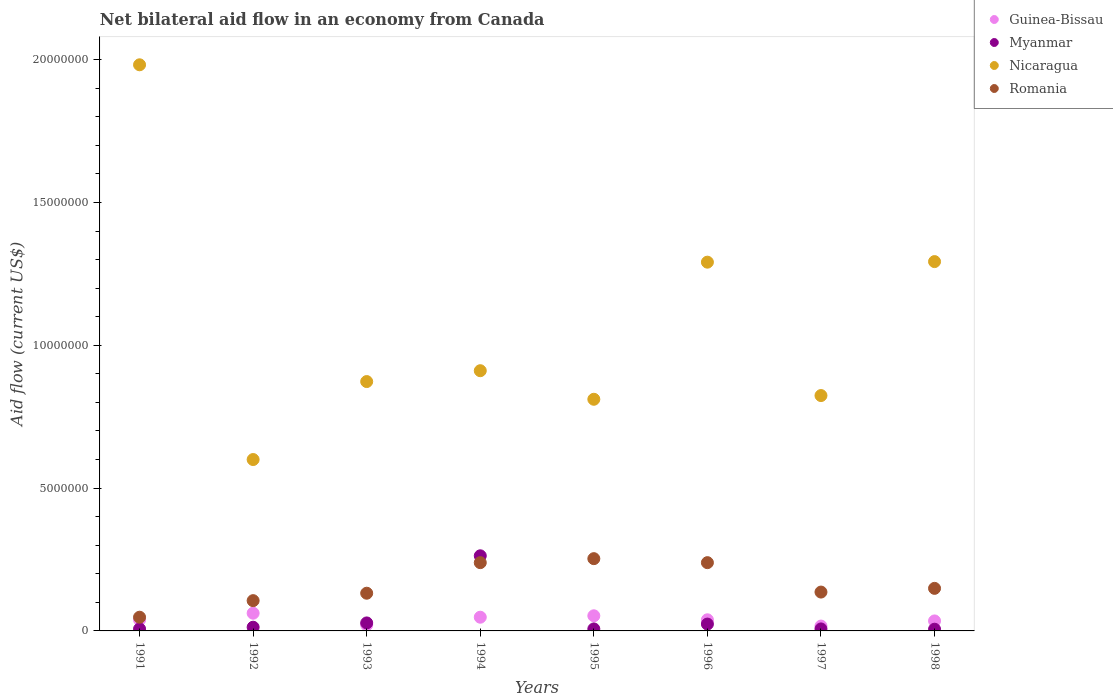Is the number of dotlines equal to the number of legend labels?
Offer a terse response. Yes. What is the net bilateral aid flow in Guinea-Bissau in 1998?
Your answer should be very brief. 3.50e+05. Across all years, what is the maximum net bilateral aid flow in Romania?
Your answer should be very brief. 2.53e+06. What is the total net bilateral aid flow in Myanmar in the graph?
Your answer should be very brief. 3.55e+06. What is the difference between the net bilateral aid flow in Romania in 1992 and that in 1995?
Give a very brief answer. -1.47e+06. What is the difference between the net bilateral aid flow in Romania in 1998 and the net bilateral aid flow in Guinea-Bissau in 1995?
Provide a succinct answer. 9.60e+05. What is the average net bilateral aid flow in Nicaragua per year?
Keep it short and to the point. 1.07e+07. In the year 1998, what is the difference between the net bilateral aid flow in Romania and net bilateral aid flow in Guinea-Bissau?
Give a very brief answer. 1.14e+06. What is the ratio of the net bilateral aid flow in Nicaragua in 1993 to that in 1997?
Your answer should be very brief. 1.06. What is the difference between the highest and the lowest net bilateral aid flow in Nicaragua?
Keep it short and to the point. 1.38e+07. In how many years, is the net bilateral aid flow in Myanmar greater than the average net bilateral aid flow in Myanmar taken over all years?
Ensure brevity in your answer.  1. Does the net bilateral aid flow in Romania monotonically increase over the years?
Offer a very short reply. No. Is the net bilateral aid flow in Guinea-Bissau strictly greater than the net bilateral aid flow in Myanmar over the years?
Your answer should be compact. No. Is the net bilateral aid flow in Romania strictly less than the net bilateral aid flow in Myanmar over the years?
Ensure brevity in your answer.  No. What is the difference between two consecutive major ticks on the Y-axis?
Make the answer very short. 5.00e+06. Are the values on the major ticks of Y-axis written in scientific E-notation?
Your response must be concise. No. Does the graph contain grids?
Make the answer very short. No. Where does the legend appear in the graph?
Offer a very short reply. Top right. How are the legend labels stacked?
Ensure brevity in your answer.  Vertical. What is the title of the graph?
Make the answer very short. Net bilateral aid flow in an economy from Canada. Does "Saudi Arabia" appear as one of the legend labels in the graph?
Provide a succinct answer. No. What is the label or title of the Y-axis?
Provide a short and direct response. Aid flow (current US$). What is the Aid flow (current US$) in Myanmar in 1991?
Give a very brief answer. 7.00e+04. What is the Aid flow (current US$) of Nicaragua in 1991?
Provide a succinct answer. 1.98e+07. What is the Aid flow (current US$) of Romania in 1991?
Your response must be concise. 4.80e+05. What is the Aid flow (current US$) in Guinea-Bissau in 1992?
Your answer should be very brief. 6.20e+05. What is the Aid flow (current US$) of Romania in 1992?
Your response must be concise. 1.06e+06. What is the Aid flow (current US$) in Nicaragua in 1993?
Give a very brief answer. 8.73e+06. What is the Aid flow (current US$) in Romania in 1993?
Offer a very short reply. 1.32e+06. What is the Aid flow (current US$) of Guinea-Bissau in 1994?
Ensure brevity in your answer.  4.80e+05. What is the Aid flow (current US$) in Myanmar in 1994?
Ensure brevity in your answer.  2.63e+06. What is the Aid flow (current US$) of Nicaragua in 1994?
Ensure brevity in your answer.  9.11e+06. What is the Aid flow (current US$) of Romania in 1994?
Give a very brief answer. 2.39e+06. What is the Aid flow (current US$) in Guinea-Bissau in 1995?
Keep it short and to the point. 5.30e+05. What is the Aid flow (current US$) in Nicaragua in 1995?
Your response must be concise. 8.11e+06. What is the Aid flow (current US$) in Romania in 1995?
Keep it short and to the point. 2.53e+06. What is the Aid flow (current US$) of Guinea-Bissau in 1996?
Provide a succinct answer. 3.90e+05. What is the Aid flow (current US$) of Nicaragua in 1996?
Provide a short and direct response. 1.29e+07. What is the Aid flow (current US$) of Romania in 1996?
Keep it short and to the point. 2.39e+06. What is the Aid flow (current US$) of Nicaragua in 1997?
Your answer should be compact. 8.24e+06. What is the Aid flow (current US$) of Romania in 1997?
Your answer should be very brief. 1.36e+06. What is the Aid flow (current US$) in Myanmar in 1998?
Offer a terse response. 6.00e+04. What is the Aid flow (current US$) of Nicaragua in 1998?
Keep it short and to the point. 1.29e+07. What is the Aid flow (current US$) of Romania in 1998?
Provide a short and direct response. 1.49e+06. Across all years, what is the maximum Aid flow (current US$) in Guinea-Bissau?
Make the answer very short. 6.20e+05. Across all years, what is the maximum Aid flow (current US$) in Myanmar?
Your response must be concise. 2.63e+06. Across all years, what is the maximum Aid flow (current US$) in Nicaragua?
Your response must be concise. 1.98e+07. Across all years, what is the maximum Aid flow (current US$) of Romania?
Your answer should be compact. 2.53e+06. Across all years, what is the minimum Aid flow (current US$) of Guinea-Bissau?
Offer a very short reply. 1.70e+05. Across all years, what is the minimum Aid flow (current US$) in Myanmar?
Make the answer very short. 6.00e+04. Across all years, what is the minimum Aid flow (current US$) in Nicaragua?
Ensure brevity in your answer.  6.00e+06. Across all years, what is the minimum Aid flow (current US$) in Romania?
Offer a terse response. 4.80e+05. What is the total Aid flow (current US$) of Guinea-Bissau in the graph?
Provide a short and direct response. 3.14e+06. What is the total Aid flow (current US$) of Myanmar in the graph?
Give a very brief answer. 3.55e+06. What is the total Aid flow (current US$) in Nicaragua in the graph?
Offer a terse response. 8.58e+07. What is the total Aid flow (current US$) in Romania in the graph?
Your response must be concise. 1.30e+07. What is the difference between the Aid flow (current US$) of Myanmar in 1991 and that in 1992?
Your answer should be compact. -6.00e+04. What is the difference between the Aid flow (current US$) in Nicaragua in 1991 and that in 1992?
Make the answer very short. 1.38e+07. What is the difference between the Aid flow (current US$) in Romania in 1991 and that in 1992?
Ensure brevity in your answer.  -5.80e+05. What is the difference between the Aid flow (current US$) in Guinea-Bissau in 1991 and that in 1993?
Make the answer very short. 1.80e+05. What is the difference between the Aid flow (current US$) of Myanmar in 1991 and that in 1993?
Provide a succinct answer. -2.10e+05. What is the difference between the Aid flow (current US$) in Nicaragua in 1991 and that in 1993?
Keep it short and to the point. 1.11e+07. What is the difference between the Aid flow (current US$) in Romania in 1991 and that in 1993?
Provide a short and direct response. -8.40e+05. What is the difference between the Aid flow (current US$) in Myanmar in 1991 and that in 1994?
Your response must be concise. -2.56e+06. What is the difference between the Aid flow (current US$) in Nicaragua in 1991 and that in 1994?
Your answer should be compact. 1.07e+07. What is the difference between the Aid flow (current US$) of Romania in 1991 and that in 1994?
Your response must be concise. -1.91e+06. What is the difference between the Aid flow (current US$) of Guinea-Bissau in 1991 and that in 1995?
Ensure brevity in your answer.  -1.40e+05. What is the difference between the Aid flow (current US$) in Nicaragua in 1991 and that in 1995?
Give a very brief answer. 1.17e+07. What is the difference between the Aid flow (current US$) of Romania in 1991 and that in 1995?
Make the answer very short. -2.05e+06. What is the difference between the Aid flow (current US$) of Guinea-Bissau in 1991 and that in 1996?
Make the answer very short. 0. What is the difference between the Aid flow (current US$) in Myanmar in 1991 and that in 1996?
Offer a very short reply. -1.70e+05. What is the difference between the Aid flow (current US$) in Nicaragua in 1991 and that in 1996?
Offer a very short reply. 6.91e+06. What is the difference between the Aid flow (current US$) of Romania in 1991 and that in 1996?
Make the answer very short. -1.91e+06. What is the difference between the Aid flow (current US$) of Guinea-Bissau in 1991 and that in 1997?
Provide a succinct answer. 2.20e+05. What is the difference between the Aid flow (current US$) of Nicaragua in 1991 and that in 1997?
Ensure brevity in your answer.  1.16e+07. What is the difference between the Aid flow (current US$) in Romania in 1991 and that in 1997?
Give a very brief answer. -8.80e+05. What is the difference between the Aid flow (current US$) of Guinea-Bissau in 1991 and that in 1998?
Your response must be concise. 4.00e+04. What is the difference between the Aid flow (current US$) of Nicaragua in 1991 and that in 1998?
Ensure brevity in your answer.  6.89e+06. What is the difference between the Aid flow (current US$) of Romania in 1991 and that in 1998?
Your answer should be very brief. -1.01e+06. What is the difference between the Aid flow (current US$) in Nicaragua in 1992 and that in 1993?
Your response must be concise. -2.73e+06. What is the difference between the Aid flow (current US$) of Romania in 1992 and that in 1993?
Your answer should be very brief. -2.60e+05. What is the difference between the Aid flow (current US$) in Myanmar in 1992 and that in 1994?
Your response must be concise. -2.50e+06. What is the difference between the Aid flow (current US$) of Nicaragua in 1992 and that in 1994?
Keep it short and to the point. -3.11e+06. What is the difference between the Aid flow (current US$) of Romania in 1992 and that in 1994?
Keep it short and to the point. -1.33e+06. What is the difference between the Aid flow (current US$) of Myanmar in 1992 and that in 1995?
Ensure brevity in your answer.  6.00e+04. What is the difference between the Aid flow (current US$) of Nicaragua in 1992 and that in 1995?
Provide a succinct answer. -2.11e+06. What is the difference between the Aid flow (current US$) of Romania in 1992 and that in 1995?
Ensure brevity in your answer.  -1.47e+06. What is the difference between the Aid flow (current US$) of Guinea-Bissau in 1992 and that in 1996?
Your answer should be very brief. 2.30e+05. What is the difference between the Aid flow (current US$) of Nicaragua in 1992 and that in 1996?
Your answer should be very brief. -6.91e+06. What is the difference between the Aid flow (current US$) of Romania in 1992 and that in 1996?
Provide a short and direct response. -1.33e+06. What is the difference between the Aid flow (current US$) in Nicaragua in 1992 and that in 1997?
Your answer should be compact. -2.24e+06. What is the difference between the Aid flow (current US$) of Romania in 1992 and that in 1997?
Your answer should be compact. -3.00e+05. What is the difference between the Aid flow (current US$) in Nicaragua in 1992 and that in 1998?
Give a very brief answer. -6.93e+06. What is the difference between the Aid flow (current US$) of Romania in 1992 and that in 1998?
Give a very brief answer. -4.30e+05. What is the difference between the Aid flow (current US$) in Myanmar in 1993 and that in 1994?
Offer a very short reply. -2.35e+06. What is the difference between the Aid flow (current US$) of Nicaragua in 1993 and that in 1994?
Offer a terse response. -3.80e+05. What is the difference between the Aid flow (current US$) in Romania in 1993 and that in 1994?
Your answer should be compact. -1.07e+06. What is the difference between the Aid flow (current US$) of Guinea-Bissau in 1993 and that in 1995?
Keep it short and to the point. -3.20e+05. What is the difference between the Aid flow (current US$) of Myanmar in 1993 and that in 1995?
Give a very brief answer. 2.10e+05. What is the difference between the Aid flow (current US$) in Nicaragua in 1993 and that in 1995?
Provide a succinct answer. 6.20e+05. What is the difference between the Aid flow (current US$) in Romania in 1993 and that in 1995?
Offer a terse response. -1.21e+06. What is the difference between the Aid flow (current US$) in Guinea-Bissau in 1993 and that in 1996?
Make the answer very short. -1.80e+05. What is the difference between the Aid flow (current US$) in Myanmar in 1993 and that in 1996?
Give a very brief answer. 4.00e+04. What is the difference between the Aid flow (current US$) of Nicaragua in 1993 and that in 1996?
Your answer should be compact. -4.18e+06. What is the difference between the Aid flow (current US$) of Romania in 1993 and that in 1996?
Your answer should be compact. -1.07e+06. What is the difference between the Aid flow (current US$) of Myanmar in 1993 and that in 1997?
Your answer should be very brief. 2.10e+05. What is the difference between the Aid flow (current US$) of Nicaragua in 1993 and that in 1997?
Ensure brevity in your answer.  4.90e+05. What is the difference between the Aid flow (current US$) in Guinea-Bissau in 1993 and that in 1998?
Your answer should be very brief. -1.40e+05. What is the difference between the Aid flow (current US$) of Myanmar in 1993 and that in 1998?
Ensure brevity in your answer.  2.20e+05. What is the difference between the Aid flow (current US$) in Nicaragua in 1993 and that in 1998?
Offer a terse response. -4.20e+06. What is the difference between the Aid flow (current US$) of Romania in 1993 and that in 1998?
Offer a terse response. -1.70e+05. What is the difference between the Aid flow (current US$) in Guinea-Bissau in 1994 and that in 1995?
Ensure brevity in your answer.  -5.00e+04. What is the difference between the Aid flow (current US$) in Myanmar in 1994 and that in 1995?
Give a very brief answer. 2.56e+06. What is the difference between the Aid flow (current US$) in Romania in 1994 and that in 1995?
Provide a short and direct response. -1.40e+05. What is the difference between the Aid flow (current US$) of Guinea-Bissau in 1994 and that in 1996?
Your answer should be compact. 9.00e+04. What is the difference between the Aid flow (current US$) in Myanmar in 1994 and that in 1996?
Your response must be concise. 2.39e+06. What is the difference between the Aid flow (current US$) of Nicaragua in 1994 and that in 1996?
Keep it short and to the point. -3.80e+06. What is the difference between the Aid flow (current US$) in Guinea-Bissau in 1994 and that in 1997?
Keep it short and to the point. 3.10e+05. What is the difference between the Aid flow (current US$) of Myanmar in 1994 and that in 1997?
Offer a very short reply. 2.56e+06. What is the difference between the Aid flow (current US$) in Nicaragua in 1994 and that in 1997?
Give a very brief answer. 8.70e+05. What is the difference between the Aid flow (current US$) of Romania in 1994 and that in 1997?
Provide a succinct answer. 1.03e+06. What is the difference between the Aid flow (current US$) of Guinea-Bissau in 1994 and that in 1998?
Your response must be concise. 1.30e+05. What is the difference between the Aid flow (current US$) in Myanmar in 1994 and that in 1998?
Provide a short and direct response. 2.57e+06. What is the difference between the Aid flow (current US$) of Nicaragua in 1994 and that in 1998?
Make the answer very short. -3.82e+06. What is the difference between the Aid flow (current US$) in Guinea-Bissau in 1995 and that in 1996?
Ensure brevity in your answer.  1.40e+05. What is the difference between the Aid flow (current US$) of Myanmar in 1995 and that in 1996?
Your answer should be very brief. -1.70e+05. What is the difference between the Aid flow (current US$) of Nicaragua in 1995 and that in 1996?
Your answer should be compact. -4.80e+06. What is the difference between the Aid flow (current US$) in Guinea-Bissau in 1995 and that in 1997?
Your answer should be compact. 3.60e+05. What is the difference between the Aid flow (current US$) of Nicaragua in 1995 and that in 1997?
Offer a very short reply. -1.30e+05. What is the difference between the Aid flow (current US$) in Romania in 1995 and that in 1997?
Keep it short and to the point. 1.17e+06. What is the difference between the Aid flow (current US$) in Myanmar in 1995 and that in 1998?
Ensure brevity in your answer.  10000. What is the difference between the Aid flow (current US$) in Nicaragua in 1995 and that in 1998?
Make the answer very short. -4.82e+06. What is the difference between the Aid flow (current US$) of Romania in 1995 and that in 1998?
Your answer should be compact. 1.04e+06. What is the difference between the Aid flow (current US$) in Myanmar in 1996 and that in 1997?
Offer a terse response. 1.70e+05. What is the difference between the Aid flow (current US$) of Nicaragua in 1996 and that in 1997?
Provide a short and direct response. 4.67e+06. What is the difference between the Aid flow (current US$) in Romania in 1996 and that in 1997?
Your answer should be compact. 1.03e+06. What is the difference between the Aid flow (current US$) of Guinea-Bissau in 1996 and that in 1998?
Provide a succinct answer. 4.00e+04. What is the difference between the Aid flow (current US$) of Nicaragua in 1996 and that in 1998?
Give a very brief answer. -2.00e+04. What is the difference between the Aid flow (current US$) of Romania in 1996 and that in 1998?
Your answer should be compact. 9.00e+05. What is the difference between the Aid flow (current US$) of Myanmar in 1997 and that in 1998?
Give a very brief answer. 10000. What is the difference between the Aid flow (current US$) in Nicaragua in 1997 and that in 1998?
Your answer should be compact. -4.69e+06. What is the difference between the Aid flow (current US$) of Romania in 1997 and that in 1998?
Offer a very short reply. -1.30e+05. What is the difference between the Aid flow (current US$) in Guinea-Bissau in 1991 and the Aid flow (current US$) in Myanmar in 1992?
Ensure brevity in your answer.  2.60e+05. What is the difference between the Aid flow (current US$) in Guinea-Bissau in 1991 and the Aid flow (current US$) in Nicaragua in 1992?
Provide a succinct answer. -5.61e+06. What is the difference between the Aid flow (current US$) of Guinea-Bissau in 1991 and the Aid flow (current US$) of Romania in 1992?
Make the answer very short. -6.70e+05. What is the difference between the Aid flow (current US$) of Myanmar in 1991 and the Aid flow (current US$) of Nicaragua in 1992?
Provide a succinct answer. -5.93e+06. What is the difference between the Aid flow (current US$) in Myanmar in 1991 and the Aid flow (current US$) in Romania in 1992?
Offer a very short reply. -9.90e+05. What is the difference between the Aid flow (current US$) in Nicaragua in 1991 and the Aid flow (current US$) in Romania in 1992?
Make the answer very short. 1.88e+07. What is the difference between the Aid flow (current US$) in Guinea-Bissau in 1991 and the Aid flow (current US$) in Nicaragua in 1993?
Offer a terse response. -8.34e+06. What is the difference between the Aid flow (current US$) in Guinea-Bissau in 1991 and the Aid flow (current US$) in Romania in 1993?
Ensure brevity in your answer.  -9.30e+05. What is the difference between the Aid flow (current US$) of Myanmar in 1991 and the Aid flow (current US$) of Nicaragua in 1993?
Give a very brief answer. -8.66e+06. What is the difference between the Aid flow (current US$) in Myanmar in 1991 and the Aid flow (current US$) in Romania in 1993?
Give a very brief answer. -1.25e+06. What is the difference between the Aid flow (current US$) of Nicaragua in 1991 and the Aid flow (current US$) of Romania in 1993?
Offer a very short reply. 1.85e+07. What is the difference between the Aid flow (current US$) of Guinea-Bissau in 1991 and the Aid flow (current US$) of Myanmar in 1994?
Give a very brief answer. -2.24e+06. What is the difference between the Aid flow (current US$) of Guinea-Bissau in 1991 and the Aid flow (current US$) of Nicaragua in 1994?
Your answer should be compact. -8.72e+06. What is the difference between the Aid flow (current US$) in Myanmar in 1991 and the Aid flow (current US$) in Nicaragua in 1994?
Your answer should be compact. -9.04e+06. What is the difference between the Aid flow (current US$) of Myanmar in 1991 and the Aid flow (current US$) of Romania in 1994?
Provide a short and direct response. -2.32e+06. What is the difference between the Aid flow (current US$) of Nicaragua in 1991 and the Aid flow (current US$) of Romania in 1994?
Give a very brief answer. 1.74e+07. What is the difference between the Aid flow (current US$) of Guinea-Bissau in 1991 and the Aid flow (current US$) of Myanmar in 1995?
Keep it short and to the point. 3.20e+05. What is the difference between the Aid flow (current US$) in Guinea-Bissau in 1991 and the Aid flow (current US$) in Nicaragua in 1995?
Your answer should be very brief. -7.72e+06. What is the difference between the Aid flow (current US$) of Guinea-Bissau in 1991 and the Aid flow (current US$) of Romania in 1995?
Your answer should be very brief. -2.14e+06. What is the difference between the Aid flow (current US$) of Myanmar in 1991 and the Aid flow (current US$) of Nicaragua in 1995?
Provide a succinct answer. -8.04e+06. What is the difference between the Aid flow (current US$) of Myanmar in 1991 and the Aid flow (current US$) of Romania in 1995?
Ensure brevity in your answer.  -2.46e+06. What is the difference between the Aid flow (current US$) in Nicaragua in 1991 and the Aid flow (current US$) in Romania in 1995?
Provide a succinct answer. 1.73e+07. What is the difference between the Aid flow (current US$) of Guinea-Bissau in 1991 and the Aid flow (current US$) of Nicaragua in 1996?
Keep it short and to the point. -1.25e+07. What is the difference between the Aid flow (current US$) in Guinea-Bissau in 1991 and the Aid flow (current US$) in Romania in 1996?
Offer a very short reply. -2.00e+06. What is the difference between the Aid flow (current US$) of Myanmar in 1991 and the Aid flow (current US$) of Nicaragua in 1996?
Your response must be concise. -1.28e+07. What is the difference between the Aid flow (current US$) of Myanmar in 1991 and the Aid flow (current US$) of Romania in 1996?
Provide a short and direct response. -2.32e+06. What is the difference between the Aid flow (current US$) in Nicaragua in 1991 and the Aid flow (current US$) in Romania in 1996?
Make the answer very short. 1.74e+07. What is the difference between the Aid flow (current US$) in Guinea-Bissau in 1991 and the Aid flow (current US$) in Nicaragua in 1997?
Your response must be concise. -7.85e+06. What is the difference between the Aid flow (current US$) in Guinea-Bissau in 1991 and the Aid flow (current US$) in Romania in 1997?
Your answer should be compact. -9.70e+05. What is the difference between the Aid flow (current US$) of Myanmar in 1991 and the Aid flow (current US$) of Nicaragua in 1997?
Your response must be concise. -8.17e+06. What is the difference between the Aid flow (current US$) in Myanmar in 1991 and the Aid flow (current US$) in Romania in 1997?
Make the answer very short. -1.29e+06. What is the difference between the Aid flow (current US$) of Nicaragua in 1991 and the Aid flow (current US$) of Romania in 1997?
Provide a short and direct response. 1.85e+07. What is the difference between the Aid flow (current US$) in Guinea-Bissau in 1991 and the Aid flow (current US$) in Myanmar in 1998?
Keep it short and to the point. 3.30e+05. What is the difference between the Aid flow (current US$) of Guinea-Bissau in 1991 and the Aid flow (current US$) of Nicaragua in 1998?
Keep it short and to the point. -1.25e+07. What is the difference between the Aid flow (current US$) in Guinea-Bissau in 1991 and the Aid flow (current US$) in Romania in 1998?
Make the answer very short. -1.10e+06. What is the difference between the Aid flow (current US$) in Myanmar in 1991 and the Aid flow (current US$) in Nicaragua in 1998?
Offer a very short reply. -1.29e+07. What is the difference between the Aid flow (current US$) of Myanmar in 1991 and the Aid flow (current US$) of Romania in 1998?
Make the answer very short. -1.42e+06. What is the difference between the Aid flow (current US$) in Nicaragua in 1991 and the Aid flow (current US$) in Romania in 1998?
Offer a terse response. 1.83e+07. What is the difference between the Aid flow (current US$) in Guinea-Bissau in 1992 and the Aid flow (current US$) in Nicaragua in 1993?
Provide a succinct answer. -8.11e+06. What is the difference between the Aid flow (current US$) of Guinea-Bissau in 1992 and the Aid flow (current US$) of Romania in 1993?
Provide a succinct answer. -7.00e+05. What is the difference between the Aid flow (current US$) in Myanmar in 1992 and the Aid flow (current US$) in Nicaragua in 1993?
Provide a short and direct response. -8.60e+06. What is the difference between the Aid flow (current US$) of Myanmar in 1992 and the Aid flow (current US$) of Romania in 1993?
Your answer should be very brief. -1.19e+06. What is the difference between the Aid flow (current US$) in Nicaragua in 1992 and the Aid flow (current US$) in Romania in 1993?
Make the answer very short. 4.68e+06. What is the difference between the Aid flow (current US$) in Guinea-Bissau in 1992 and the Aid flow (current US$) in Myanmar in 1994?
Ensure brevity in your answer.  -2.01e+06. What is the difference between the Aid flow (current US$) of Guinea-Bissau in 1992 and the Aid flow (current US$) of Nicaragua in 1994?
Give a very brief answer. -8.49e+06. What is the difference between the Aid flow (current US$) of Guinea-Bissau in 1992 and the Aid flow (current US$) of Romania in 1994?
Ensure brevity in your answer.  -1.77e+06. What is the difference between the Aid flow (current US$) of Myanmar in 1992 and the Aid flow (current US$) of Nicaragua in 1994?
Provide a short and direct response. -8.98e+06. What is the difference between the Aid flow (current US$) in Myanmar in 1992 and the Aid flow (current US$) in Romania in 1994?
Offer a terse response. -2.26e+06. What is the difference between the Aid flow (current US$) in Nicaragua in 1992 and the Aid flow (current US$) in Romania in 1994?
Give a very brief answer. 3.61e+06. What is the difference between the Aid flow (current US$) of Guinea-Bissau in 1992 and the Aid flow (current US$) of Nicaragua in 1995?
Give a very brief answer. -7.49e+06. What is the difference between the Aid flow (current US$) in Guinea-Bissau in 1992 and the Aid flow (current US$) in Romania in 1995?
Your response must be concise. -1.91e+06. What is the difference between the Aid flow (current US$) of Myanmar in 1992 and the Aid flow (current US$) of Nicaragua in 1995?
Give a very brief answer. -7.98e+06. What is the difference between the Aid flow (current US$) of Myanmar in 1992 and the Aid flow (current US$) of Romania in 1995?
Your answer should be very brief. -2.40e+06. What is the difference between the Aid flow (current US$) in Nicaragua in 1992 and the Aid flow (current US$) in Romania in 1995?
Provide a short and direct response. 3.47e+06. What is the difference between the Aid flow (current US$) in Guinea-Bissau in 1992 and the Aid flow (current US$) in Nicaragua in 1996?
Ensure brevity in your answer.  -1.23e+07. What is the difference between the Aid flow (current US$) of Guinea-Bissau in 1992 and the Aid flow (current US$) of Romania in 1996?
Ensure brevity in your answer.  -1.77e+06. What is the difference between the Aid flow (current US$) of Myanmar in 1992 and the Aid flow (current US$) of Nicaragua in 1996?
Offer a very short reply. -1.28e+07. What is the difference between the Aid flow (current US$) of Myanmar in 1992 and the Aid flow (current US$) of Romania in 1996?
Provide a short and direct response. -2.26e+06. What is the difference between the Aid flow (current US$) in Nicaragua in 1992 and the Aid flow (current US$) in Romania in 1996?
Your answer should be very brief. 3.61e+06. What is the difference between the Aid flow (current US$) of Guinea-Bissau in 1992 and the Aid flow (current US$) of Myanmar in 1997?
Make the answer very short. 5.50e+05. What is the difference between the Aid flow (current US$) of Guinea-Bissau in 1992 and the Aid flow (current US$) of Nicaragua in 1997?
Your answer should be compact. -7.62e+06. What is the difference between the Aid flow (current US$) in Guinea-Bissau in 1992 and the Aid flow (current US$) in Romania in 1997?
Ensure brevity in your answer.  -7.40e+05. What is the difference between the Aid flow (current US$) of Myanmar in 1992 and the Aid flow (current US$) of Nicaragua in 1997?
Your answer should be very brief. -8.11e+06. What is the difference between the Aid flow (current US$) of Myanmar in 1992 and the Aid flow (current US$) of Romania in 1997?
Offer a terse response. -1.23e+06. What is the difference between the Aid flow (current US$) of Nicaragua in 1992 and the Aid flow (current US$) of Romania in 1997?
Your answer should be compact. 4.64e+06. What is the difference between the Aid flow (current US$) in Guinea-Bissau in 1992 and the Aid flow (current US$) in Myanmar in 1998?
Your answer should be very brief. 5.60e+05. What is the difference between the Aid flow (current US$) of Guinea-Bissau in 1992 and the Aid flow (current US$) of Nicaragua in 1998?
Your answer should be compact. -1.23e+07. What is the difference between the Aid flow (current US$) in Guinea-Bissau in 1992 and the Aid flow (current US$) in Romania in 1998?
Offer a very short reply. -8.70e+05. What is the difference between the Aid flow (current US$) of Myanmar in 1992 and the Aid flow (current US$) of Nicaragua in 1998?
Provide a succinct answer. -1.28e+07. What is the difference between the Aid flow (current US$) in Myanmar in 1992 and the Aid flow (current US$) in Romania in 1998?
Your answer should be very brief. -1.36e+06. What is the difference between the Aid flow (current US$) of Nicaragua in 1992 and the Aid flow (current US$) of Romania in 1998?
Offer a very short reply. 4.51e+06. What is the difference between the Aid flow (current US$) of Guinea-Bissau in 1993 and the Aid flow (current US$) of Myanmar in 1994?
Your answer should be compact. -2.42e+06. What is the difference between the Aid flow (current US$) in Guinea-Bissau in 1993 and the Aid flow (current US$) in Nicaragua in 1994?
Offer a terse response. -8.90e+06. What is the difference between the Aid flow (current US$) in Guinea-Bissau in 1993 and the Aid flow (current US$) in Romania in 1994?
Your answer should be very brief. -2.18e+06. What is the difference between the Aid flow (current US$) in Myanmar in 1993 and the Aid flow (current US$) in Nicaragua in 1994?
Offer a terse response. -8.83e+06. What is the difference between the Aid flow (current US$) in Myanmar in 1993 and the Aid flow (current US$) in Romania in 1994?
Make the answer very short. -2.11e+06. What is the difference between the Aid flow (current US$) of Nicaragua in 1993 and the Aid flow (current US$) of Romania in 1994?
Give a very brief answer. 6.34e+06. What is the difference between the Aid flow (current US$) in Guinea-Bissau in 1993 and the Aid flow (current US$) in Myanmar in 1995?
Make the answer very short. 1.40e+05. What is the difference between the Aid flow (current US$) in Guinea-Bissau in 1993 and the Aid flow (current US$) in Nicaragua in 1995?
Your response must be concise. -7.90e+06. What is the difference between the Aid flow (current US$) in Guinea-Bissau in 1993 and the Aid flow (current US$) in Romania in 1995?
Give a very brief answer. -2.32e+06. What is the difference between the Aid flow (current US$) of Myanmar in 1993 and the Aid flow (current US$) of Nicaragua in 1995?
Your answer should be very brief. -7.83e+06. What is the difference between the Aid flow (current US$) of Myanmar in 1993 and the Aid flow (current US$) of Romania in 1995?
Your answer should be compact. -2.25e+06. What is the difference between the Aid flow (current US$) in Nicaragua in 1993 and the Aid flow (current US$) in Romania in 1995?
Make the answer very short. 6.20e+06. What is the difference between the Aid flow (current US$) of Guinea-Bissau in 1993 and the Aid flow (current US$) of Nicaragua in 1996?
Provide a succinct answer. -1.27e+07. What is the difference between the Aid flow (current US$) in Guinea-Bissau in 1993 and the Aid flow (current US$) in Romania in 1996?
Your answer should be compact. -2.18e+06. What is the difference between the Aid flow (current US$) of Myanmar in 1993 and the Aid flow (current US$) of Nicaragua in 1996?
Ensure brevity in your answer.  -1.26e+07. What is the difference between the Aid flow (current US$) of Myanmar in 1993 and the Aid flow (current US$) of Romania in 1996?
Give a very brief answer. -2.11e+06. What is the difference between the Aid flow (current US$) of Nicaragua in 1993 and the Aid flow (current US$) of Romania in 1996?
Provide a short and direct response. 6.34e+06. What is the difference between the Aid flow (current US$) in Guinea-Bissau in 1993 and the Aid flow (current US$) in Myanmar in 1997?
Provide a short and direct response. 1.40e+05. What is the difference between the Aid flow (current US$) in Guinea-Bissau in 1993 and the Aid flow (current US$) in Nicaragua in 1997?
Ensure brevity in your answer.  -8.03e+06. What is the difference between the Aid flow (current US$) in Guinea-Bissau in 1993 and the Aid flow (current US$) in Romania in 1997?
Provide a short and direct response. -1.15e+06. What is the difference between the Aid flow (current US$) of Myanmar in 1993 and the Aid flow (current US$) of Nicaragua in 1997?
Give a very brief answer. -7.96e+06. What is the difference between the Aid flow (current US$) of Myanmar in 1993 and the Aid flow (current US$) of Romania in 1997?
Keep it short and to the point. -1.08e+06. What is the difference between the Aid flow (current US$) in Nicaragua in 1993 and the Aid flow (current US$) in Romania in 1997?
Provide a short and direct response. 7.37e+06. What is the difference between the Aid flow (current US$) in Guinea-Bissau in 1993 and the Aid flow (current US$) in Myanmar in 1998?
Your response must be concise. 1.50e+05. What is the difference between the Aid flow (current US$) in Guinea-Bissau in 1993 and the Aid flow (current US$) in Nicaragua in 1998?
Provide a succinct answer. -1.27e+07. What is the difference between the Aid flow (current US$) of Guinea-Bissau in 1993 and the Aid flow (current US$) of Romania in 1998?
Offer a terse response. -1.28e+06. What is the difference between the Aid flow (current US$) of Myanmar in 1993 and the Aid flow (current US$) of Nicaragua in 1998?
Ensure brevity in your answer.  -1.26e+07. What is the difference between the Aid flow (current US$) in Myanmar in 1993 and the Aid flow (current US$) in Romania in 1998?
Ensure brevity in your answer.  -1.21e+06. What is the difference between the Aid flow (current US$) of Nicaragua in 1993 and the Aid flow (current US$) of Romania in 1998?
Provide a succinct answer. 7.24e+06. What is the difference between the Aid flow (current US$) in Guinea-Bissau in 1994 and the Aid flow (current US$) in Nicaragua in 1995?
Your answer should be compact. -7.63e+06. What is the difference between the Aid flow (current US$) in Guinea-Bissau in 1994 and the Aid flow (current US$) in Romania in 1995?
Provide a short and direct response. -2.05e+06. What is the difference between the Aid flow (current US$) of Myanmar in 1994 and the Aid flow (current US$) of Nicaragua in 1995?
Offer a very short reply. -5.48e+06. What is the difference between the Aid flow (current US$) in Myanmar in 1994 and the Aid flow (current US$) in Romania in 1995?
Ensure brevity in your answer.  1.00e+05. What is the difference between the Aid flow (current US$) of Nicaragua in 1994 and the Aid flow (current US$) of Romania in 1995?
Offer a terse response. 6.58e+06. What is the difference between the Aid flow (current US$) in Guinea-Bissau in 1994 and the Aid flow (current US$) in Nicaragua in 1996?
Provide a succinct answer. -1.24e+07. What is the difference between the Aid flow (current US$) of Guinea-Bissau in 1994 and the Aid flow (current US$) of Romania in 1996?
Provide a succinct answer. -1.91e+06. What is the difference between the Aid flow (current US$) in Myanmar in 1994 and the Aid flow (current US$) in Nicaragua in 1996?
Provide a short and direct response. -1.03e+07. What is the difference between the Aid flow (current US$) of Nicaragua in 1994 and the Aid flow (current US$) of Romania in 1996?
Provide a short and direct response. 6.72e+06. What is the difference between the Aid flow (current US$) of Guinea-Bissau in 1994 and the Aid flow (current US$) of Myanmar in 1997?
Provide a succinct answer. 4.10e+05. What is the difference between the Aid flow (current US$) in Guinea-Bissau in 1994 and the Aid flow (current US$) in Nicaragua in 1997?
Provide a succinct answer. -7.76e+06. What is the difference between the Aid flow (current US$) of Guinea-Bissau in 1994 and the Aid flow (current US$) of Romania in 1997?
Provide a succinct answer. -8.80e+05. What is the difference between the Aid flow (current US$) in Myanmar in 1994 and the Aid flow (current US$) in Nicaragua in 1997?
Make the answer very short. -5.61e+06. What is the difference between the Aid flow (current US$) in Myanmar in 1994 and the Aid flow (current US$) in Romania in 1997?
Offer a very short reply. 1.27e+06. What is the difference between the Aid flow (current US$) of Nicaragua in 1994 and the Aid flow (current US$) of Romania in 1997?
Keep it short and to the point. 7.75e+06. What is the difference between the Aid flow (current US$) in Guinea-Bissau in 1994 and the Aid flow (current US$) in Myanmar in 1998?
Your answer should be compact. 4.20e+05. What is the difference between the Aid flow (current US$) of Guinea-Bissau in 1994 and the Aid flow (current US$) of Nicaragua in 1998?
Your answer should be very brief. -1.24e+07. What is the difference between the Aid flow (current US$) in Guinea-Bissau in 1994 and the Aid flow (current US$) in Romania in 1998?
Your answer should be compact. -1.01e+06. What is the difference between the Aid flow (current US$) in Myanmar in 1994 and the Aid flow (current US$) in Nicaragua in 1998?
Make the answer very short. -1.03e+07. What is the difference between the Aid flow (current US$) in Myanmar in 1994 and the Aid flow (current US$) in Romania in 1998?
Ensure brevity in your answer.  1.14e+06. What is the difference between the Aid flow (current US$) of Nicaragua in 1994 and the Aid flow (current US$) of Romania in 1998?
Your answer should be compact. 7.62e+06. What is the difference between the Aid flow (current US$) of Guinea-Bissau in 1995 and the Aid flow (current US$) of Myanmar in 1996?
Provide a short and direct response. 2.90e+05. What is the difference between the Aid flow (current US$) of Guinea-Bissau in 1995 and the Aid flow (current US$) of Nicaragua in 1996?
Ensure brevity in your answer.  -1.24e+07. What is the difference between the Aid flow (current US$) in Guinea-Bissau in 1995 and the Aid flow (current US$) in Romania in 1996?
Your answer should be compact. -1.86e+06. What is the difference between the Aid flow (current US$) in Myanmar in 1995 and the Aid flow (current US$) in Nicaragua in 1996?
Offer a terse response. -1.28e+07. What is the difference between the Aid flow (current US$) of Myanmar in 1995 and the Aid flow (current US$) of Romania in 1996?
Offer a very short reply. -2.32e+06. What is the difference between the Aid flow (current US$) of Nicaragua in 1995 and the Aid flow (current US$) of Romania in 1996?
Provide a succinct answer. 5.72e+06. What is the difference between the Aid flow (current US$) in Guinea-Bissau in 1995 and the Aid flow (current US$) in Myanmar in 1997?
Provide a short and direct response. 4.60e+05. What is the difference between the Aid flow (current US$) of Guinea-Bissau in 1995 and the Aid flow (current US$) of Nicaragua in 1997?
Your response must be concise. -7.71e+06. What is the difference between the Aid flow (current US$) in Guinea-Bissau in 1995 and the Aid flow (current US$) in Romania in 1997?
Make the answer very short. -8.30e+05. What is the difference between the Aid flow (current US$) in Myanmar in 1995 and the Aid flow (current US$) in Nicaragua in 1997?
Offer a very short reply. -8.17e+06. What is the difference between the Aid flow (current US$) of Myanmar in 1995 and the Aid flow (current US$) of Romania in 1997?
Make the answer very short. -1.29e+06. What is the difference between the Aid flow (current US$) of Nicaragua in 1995 and the Aid flow (current US$) of Romania in 1997?
Give a very brief answer. 6.75e+06. What is the difference between the Aid flow (current US$) of Guinea-Bissau in 1995 and the Aid flow (current US$) of Myanmar in 1998?
Your answer should be compact. 4.70e+05. What is the difference between the Aid flow (current US$) of Guinea-Bissau in 1995 and the Aid flow (current US$) of Nicaragua in 1998?
Offer a terse response. -1.24e+07. What is the difference between the Aid flow (current US$) of Guinea-Bissau in 1995 and the Aid flow (current US$) of Romania in 1998?
Offer a terse response. -9.60e+05. What is the difference between the Aid flow (current US$) in Myanmar in 1995 and the Aid flow (current US$) in Nicaragua in 1998?
Give a very brief answer. -1.29e+07. What is the difference between the Aid flow (current US$) of Myanmar in 1995 and the Aid flow (current US$) of Romania in 1998?
Your answer should be compact. -1.42e+06. What is the difference between the Aid flow (current US$) of Nicaragua in 1995 and the Aid flow (current US$) of Romania in 1998?
Your response must be concise. 6.62e+06. What is the difference between the Aid flow (current US$) of Guinea-Bissau in 1996 and the Aid flow (current US$) of Myanmar in 1997?
Ensure brevity in your answer.  3.20e+05. What is the difference between the Aid flow (current US$) of Guinea-Bissau in 1996 and the Aid flow (current US$) of Nicaragua in 1997?
Ensure brevity in your answer.  -7.85e+06. What is the difference between the Aid flow (current US$) of Guinea-Bissau in 1996 and the Aid flow (current US$) of Romania in 1997?
Your answer should be compact. -9.70e+05. What is the difference between the Aid flow (current US$) in Myanmar in 1996 and the Aid flow (current US$) in Nicaragua in 1997?
Give a very brief answer. -8.00e+06. What is the difference between the Aid flow (current US$) of Myanmar in 1996 and the Aid flow (current US$) of Romania in 1997?
Keep it short and to the point. -1.12e+06. What is the difference between the Aid flow (current US$) of Nicaragua in 1996 and the Aid flow (current US$) of Romania in 1997?
Your response must be concise. 1.16e+07. What is the difference between the Aid flow (current US$) in Guinea-Bissau in 1996 and the Aid flow (current US$) in Myanmar in 1998?
Offer a very short reply. 3.30e+05. What is the difference between the Aid flow (current US$) of Guinea-Bissau in 1996 and the Aid flow (current US$) of Nicaragua in 1998?
Ensure brevity in your answer.  -1.25e+07. What is the difference between the Aid flow (current US$) in Guinea-Bissau in 1996 and the Aid flow (current US$) in Romania in 1998?
Keep it short and to the point. -1.10e+06. What is the difference between the Aid flow (current US$) of Myanmar in 1996 and the Aid flow (current US$) of Nicaragua in 1998?
Provide a short and direct response. -1.27e+07. What is the difference between the Aid flow (current US$) of Myanmar in 1996 and the Aid flow (current US$) of Romania in 1998?
Make the answer very short. -1.25e+06. What is the difference between the Aid flow (current US$) in Nicaragua in 1996 and the Aid flow (current US$) in Romania in 1998?
Ensure brevity in your answer.  1.14e+07. What is the difference between the Aid flow (current US$) in Guinea-Bissau in 1997 and the Aid flow (current US$) in Myanmar in 1998?
Offer a very short reply. 1.10e+05. What is the difference between the Aid flow (current US$) in Guinea-Bissau in 1997 and the Aid flow (current US$) in Nicaragua in 1998?
Provide a short and direct response. -1.28e+07. What is the difference between the Aid flow (current US$) of Guinea-Bissau in 1997 and the Aid flow (current US$) of Romania in 1998?
Offer a terse response. -1.32e+06. What is the difference between the Aid flow (current US$) in Myanmar in 1997 and the Aid flow (current US$) in Nicaragua in 1998?
Your answer should be very brief. -1.29e+07. What is the difference between the Aid flow (current US$) of Myanmar in 1997 and the Aid flow (current US$) of Romania in 1998?
Provide a short and direct response. -1.42e+06. What is the difference between the Aid flow (current US$) in Nicaragua in 1997 and the Aid flow (current US$) in Romania in 1998?
Your answer should be compact. 6.75e+06. What is the average Aid flow (current US$) in Guinea-Bissau per year?
Ensure brevity in your answer.  3.92e+05. What is the average Aid flow (current US$) of Myanmar per year?
Give a very brief answer. 4.44e+05. What is the average Aid flow (current US$) in Nicaragua per year?
Your answer should be compact. 1.07e+07. What is the average Aid flow (current US$) in Romania per year?
Give a very brief answer. 1.63e+06. In the year 1991, what is the difference between the Aid flow (current US$) of Guinea-Bissau and Aid flow (current US$) of Nicaragua?
Keep it short and to the point. -1.94e+07. In the year 1991, what is the difference between the Aid flow (current US$) of Myanmar and Aid flow (current US$) of Nicaragua?
Give a very brief answer. -1.98e+07. In the year 1991, what is the difference between the Aid flow (current US$) in Myanmar and Aid flow (current US$) in Romania?
Ensure brevity in your answer.  -4.10e+05. In the year 1991, what is the difference between the Aid flow (current US$) in Nicaragua and Aid flow (current US$) in Romania?
Provide a succinct answer. 1.93e+07. In the year 1992, what is the difference between the Aid flow (current US$) in Guinea-Bissau and Aid flow (current US$) in Myanmar?
Keep it short and to the point. 4.90e+05. In the year 1992, what is the difference between the Aid flow (current US$) of Guinea-Bissau and Aid flow (current US$) of Nicaragua?
Your response must be concise. -5.38e+06. In the year 1992, what is the difference between the Aid flow (current US$) of Guinea-Bissau and Aid flow (current US$) of Romania?
Your answer should be compact. -4.40e+05. In the year 1992, what is the difference between the Aid flow (current US$) of Myanmar and Aid flow (current US$) of Nicaragua?
Offer a very short reply. -5.87e+06. In the year 1992, what is the difference between the Aid flow (current US$) in Myanmar and Aid flow (current US$) in Romania?
Your answer should be very brief. -9.30e+05. In the year 1992, what is the difference between the Aid flow (current US$) of Nicaragua and Aid flow (current US$) of Romania?
Your answer should be compact. 4.94e+06. In the year 1993, what is the difference between the Aid flow (current US$) of Guinea-Bissau and Aid flow (current US$) of Nicaragua?
Your answer should be compact. -8.52e+06. In the year 1993, what is the difference between the Aid flow (current US$) of Guinea-Bissau and Aid flow (current US$) of Romania?
Offer a terse response. -1.11e+06. In the year 1993, what is the difference between the Aid flow (current US$) of Myanmar and Aid flow (current US$) of Nicaragua?
Offer a terse response. -8.45e+06. In the year 1993, what is the difference between the Aid flow (current US$) in Myanmar and Aid flow (current US$) in Romania?
Offer a terse response. -1.04e+06. In the year 1993, what is the difference between the Aid flow (current US$) in Nicaragua and Aid flow (current US$) in Romania?
Your answer should be very brief. 7.41e+06. In the year 1994, what is the difference between the Aid flow (current US$) of Guinea-Bissau and Aid flow (current US$) of Myanmar?
Provide a succinct answer. -2.15e+06. In the year 1994, what is the difference between the Aid flow (current US$) of Guinea-Bissau and Aid flow (current US$) of Nicaragua?
Keep it short and to the point. -8.63e+06. In the year 1994, what is the difference between the Aid flow (current US$) in Guinea-Bissau and Aid flow (current US$) in Romania?
Give a very brief answer. -1.91e+06. In the year 1994, what is the difference between the Aid flow (current US$) in Myanmar and Aid flow (current US$) in Nicaragua?
Offer a very short reply. -6.48e+06. In the year 1994, what is the difference between the Aid flow (current US$) in Myanmar and Aid flow (current US$) in Romania?
Ensure brevity in your answer.  2.40e+05. In the year 1994, what is the difference between the Aid flow (current US$) of Nicaragua and Aid flow (current US$) of Romania?
Give a very brief answer. 6.72e+06. In the year 1995, what is the difference between the Aid flow (current US$) of Guinea-Bissau and Aid flow (current US$) of Nicaragua?
Your answer should be compact. -7.58e+06. In the year 1995, what is the difference between the Aid flow (current US$) of Myanmar and Aid flow (current US$) of Nicaragua?
Your response must be concise. -8.04e+06. In the year 1995, what is the difference between the Aid flow (current US$) of Myanmar and Aid flow (current US$) of Romania?
Ensure brevity in your answer.  -2.46e+06. In the year 1995, what is the difference between the Aid flow (current US$) of Nicaragua and Aid flow (current US$) of Romania?
Your answer should be very brief. 5.58e+06. In the year 1996, what is the difference between the Aid flow (current US$) in Guinea-Bissau and Aid flow (current US$) in Myanmar?
Offer a very short reply. 1.50e+05. In the year 1996, what is the difference between the Aid flow (current US$) in Guinea-Bissau and Aid flow (current US$) in Nicaragua?
Your answer should be compact. -1.25e+07. In the year 1996, what is the difference between the Aid flow (current US$) in Guinea-Bissau and Aid flow (current US$) in Romania?
Ensure brevity in your answer.  -2.00e+06. In the year 1996, what is the difference between the Aid flow (current US$) in Myanmar and Aid flow (current US$) in Nicaragua?
Give a very brief answer. -1.27e+07. In the year 1996, what is the difference between the Aid flow (current US$) in Myanmar and Aid flow (current US$) in Romania?
Your answer should be compact. -2.15e+06. In the year 1996, what is the difference between the Aid flow (current US$) in Nicaragua and Aid flow (current US$) in Romania?
Your answer should be very brief. 1.05e+07. In the year 1997, what is the difference between the Aid flow (current US$) in Guinea-Bissau and Aid flow (current US$) in Myanmar?
Make the answer very short. 1.00e+05. In the year 1997, what is the difference between the Aid flow (current US$) of Guinea-Bissau and Aid flow (current US$) of Nicaragua?
Make the answer very short. -8.07e+06. In the year 1997, what is the difference between the Aid flow (current US$) of Guinea-Bissau and Aid flow (current US$) of Romania?
Your response must be concise. -1.19e+06. In the year 1997, what is the difference between the Aid flow (current US$) in Myanmar and Aid flow (current US$) in Nicaragua?
Give a very brief answer. -8.17e+06. In the year 1997, what is the difference between the Aid flow (current US$) of Myanmar and Aid flow (current US$) of Romania?
Keep it short and to the point. -1.29e+06. In the year 1997, what is the difference between the Aid flow (current US$) of Nicaragua and Aid flow (current US$) of Romania?
Ensure brevity in your answer.  6.88e+06. In the year 1998, what is the difference between the Aid flow (current US$) in Guinea-Bissau and Aid flow (current US$) in Nicaragua?
Give a very brief answer. -1.26e+07. In the year 1998, what is the difference between the Aid flow (current US$) of Guinea-Bissau and Aid flow (current US$) of Romania?
Provide a succinct answer. -1.14e+06. In the year 1998, what is the difference between the Aid flow (current US$) in Myanmar and Aid flow (current US$) in Nicaragua?
Make the answer very short. -1.29e+07. In the year 1998, what is the difference between the Aid flow (current US$) of Myanmar and Aid flow (current US$) of Romania?
Your response must be concise. -1.43e+06. In the year 1998, what is the difference between the Aid flow (current US$) of Nicaragua and Aid flow (current US$) of Romania?
Your answer should be very brief. 1.14e+07. What is the ratio of the Aid flow (current US$) in Guinea-Bissau in 1991 to that in 1992?
Offer a terse response. 0.63. What is the ratio of the Aid flow (current US$) of Myanmar in 1991 to that in 1992?
Offer a terse response. 0.54. What is the ratio of the Aid flow (current US$) of Nicaragua in 1991 to that in 1992?
Ensure brevity in your answer.  3.3. What is the ratio of the Aid flow (current US$) of Romania in 1991 to that in 1992?
Give a very brief answer. 0.45. What is the ratio of the Aid flow (current US$) of Guinea-Bissau in 1991 to that in 1993?
Provide a short and direct response. 1.86. What is the ratio of the Aid flow (current US$) of Nicaragua in 1991 to that in 1993?
Offer a terse response. 2.27. What is the ratio of the Aid flow (current US$) of Romania in 1991 to that in 1993?
Ensure brevity in your answer.  0.36. What is the ratio of the Aid flow (current US$) of Guinea-Bissau in 1991 to that in 1994?
Provide a succinct answer. 0.81. What is the ratio of the Aid flow (current US$) in Myanmar in 1991 to that in 1994?
Offer a terse response. 0.03. What is the ratio of the Aid flow (current US$) in Nicaragua in 1991 to that in 1994?
Offer a terse response. 2.18. What is the ratio of the Aid flow (current US$) of Romania in 1991 to that in 1994?
Give a very brief answer. 0.2. What is the ratio of the Aid flow (current US$) in Guinea-Bissau in 1991 to that in 1995?
Provide a short and direct response. 0.74. What is the ratio of the Aid flow (current US$) in Nicaragua in 1991 to that in 1995?
Give a very brief answer. 2.44. What is the ratio of the Aid flow (current US$) of Romania in 1991 to that in 1995?
Give a very brief answer. 0.19. What is the ratio of the Aid flow (current US$) of Guinea-Bissau in 1991 to that in 1996?
Make the answer very short. 1. What is the ratio of the Aid flow (current US$) of Myanmar in 1991 to that in 1996?
Offer a very short reply. 0.29. What is the ratio of the Aid flow (current US$) of Nicaragua in 1991 to that in 1996?
Offer a terse response. 1.54. What is the ratio of the Aid flow (current US$) of Romania in 1991 to that in 1996?
Provide a succinct answer. 0.2. What is the ratio of the Aid flow (current US$) of Guinea-Bissau in 1991 to that in 1997?
Ensure brevity in your answer.  2.29. What is the ratio of the Aid flow (current US$) of Nicaragua in 1991 to that in 1997?
Ensure brevity in your answer.  2.41. What is the ratio of the Aid flow (current US$) in Romania in 1991 to that in 1997?
Your answer should be very brief. 0.35. What is the ratio of the Aid flow (current US$) in Guinea-Bissau in 1991 to that in 1998?
Your response must be concise. 1.11. What is the ratio of the Aid flow (current US$) in Nicaragua in 1991 to that in 1998?
Provide a succinct answer. 1.53. What is the ratio of the Aid flow (current US$) in Romania in 1991 to that in 1998?
Provide a short and direct response. 0.32. What is the ratio of the Aid flow (current US$) in Guinea-Bissau in 1992 to that in 1993?
Offer a terse response. 2.95. What is the ratio of the Aid flow (current US$) in Myanmar in 1992 to that in 1993?
Provide a succinct answer. 0.46. What is the ratio of the Aid flow (current US$) in Nicaragua in 1992 to that in 1993?
Your response must be concise. 0.69. What is the ratio of the Aid flow (current US$) in Romania in 1992 to that in 1993?
Provide a succinct answer. 0.8. What is the ratio of the Aid flow (current US$) in Guinea-Bissau in 1992 to that in 1994?
Keep it short and to the point. 1.29. What is the ratio of the Aid flow (current US$) of Myanmar in 1992 to that in 1994?
Provide a short and direct response. 0.05. What is the ratio of the Aid flow (current US$) in Nicaragua in 1992 to that in 1994?
Provide a short and direct response. 0.66. What is the ratio of the Aid flow (current US$) in Romania in 1992 to that in 1994?
Provide a succinct answer. 0.44. What is the ratio of the Aid flow (current US$) in Guinea-Bissau in 1992 to that in 1995?
Provide a short and direct response. 1.17. What is the ratio of the Aid flow (current US$) in Myanmar in 1992 to that in 1995?
Provide a short and direct response. 1.86. What is the ratio of the Aid flow (current US$) in Nicaragua in 1992 to that in 1995?
Ensure brevity in your answer.  0.74. What is the ratio of the Aid flow (current US$) in Romania in 1992 to that in 1995?
Make the answer very short. 0.42. What is the ratio of the Aid flow (current US$) of Guinea-Bissau in 1992 to that in 1996?
Your answer should be very brief. 1.59. What is the ratio of the Aid flow (current US$) in Myanmar in 1992 to that in 1996?
Your answer should be compact. 0.54. What is the ratio of the Aid flow (current US$) in Nicaragua in 1992 to that in 1996?
Offer a terse response. 0.46. What is the ratio of the Aid flow (current US$) of Romania in 1992 to that in 1996?
Make the answer very short. 0.44. What is the ratio of the Aid flow (current US$) of Guinea-Bissau in 1992 to that in 1997?
Keep it short and to the point. 3.65. What is the ratio of the Aid flow (current US$) in Myanmar in 1992 to that in 1997?
Make the answer very short. 1.86. What is the ratio of the Aid flow (current US$) in Nicaragua in 1992 to that in 1997?
Ensure brevity in your answer.  0.73. What is the ratio of the Aid flow (current US$) in Romania in 1992 to that in 1997?
Offer a very short reply. 0.78. What is the ratio of the Aid flow (current US$) in Guinea-Bissau in 1992 to that in 1998?
Keep it short and to the point. 1.77. What is the ratio of the Aid flow (current US$) of Myanmar in 1992 to that in 1998?
Keep it short and to the point. 2.17. What is the ratio of the Aid flow (current US$) in Nicaragua in 1992 to that in 1998?
Make the answer very short. 0.46. What is the ratio of the Aid flow (current US$) in Romania in 1992 to that in 1998?
Offer a terse response. 0.71. What is the ratio of the Aid flow (current US$) in Guinea-Bissau in 1993 to that in 1994?
Keep it short and to the point. 0.44. What is the ratio of the Aid flow (current US$) in Myanmar in 1993 to that in 1994?
Ensure brevity in your answer.  0.11. What is the ratio of the Aid flow (current US$) of Nicaragua in 1993 to that in 1994?
Ensure brevity in your answer.  0.96. What is the ratio of the Aid flow (current US$) in Romania in 1993 to that in 1994?
Offer a very short reply. 0.55. What is the ratio of the Aid flow (current US$) of Guinea-Bissau in 1993 to that in 1995?
Offer a very short reply. 0.4. What is the ratio of the Aid flow (current US$) of Myanmar in 1993 to that in 1995?
Your answer should be very brief. 4. What is the ratio of the Aid flow (current US$) of Nicaragua in 1993 to that in 1995?
Provide a succinct answer. 1.08. What is the ratio of the Aid flow (current US$) of Romania in 1993 to that in 1995?
Offer a very short reply. 0.52. What is the ratio of the Aid flow (current US$) in Guinea-Bissau in 1993 to that in 1996?
Keep it short and to the point. 0.54. What is the ratio of the Aid flow (current US$) in Myanmar in 1993 to that in 1996?
Your answer should be very brief. 1.17. What is the ratio of the Aid flow (current US$) in Nicaragua in 1993 to that in 1996?
Provide a short and direct response. 0.68. What is the ratio of the Aid flow (current US$) in Romania in 1993 to that in 1996?
Make the answer very short. 0.55. What is the ratio of the Aid flow (current US$) of Guinea-Bissau in 1993 to that in 1997?
Make the answer very short. 1.24. What is the ratio of the Aid flow (current US$) of Nicaragua in 1993 to that in 1997?
Make the answer very short. 1.06. What is the ratio of the Aid flow (current US$) in Romania in 1993 to that in 1997?
Offer a terse response. 0.97. What is the ratio of the Aid flow (current US$) in Guinea-Bissau in 1993 to that in 1998?
Your answer should be compact. 0.6. What is the ratio of the Aid flow (current US$) in Myanmar in 1993 to that in 1998?
Offer a very short reply. 4.67. What is the ratio of the Aid flow (current US$) of Nicaragua in 1993 to that in 1998?
Your response must be concise. 0.68. What is the ratio of the Aid flow (current US$) of Romania in 1993 to that in 1998?
Keep it short and to the point. 0.89. What is the ratio of the Aid flow (current US$) in Guinea-Bissau in 1994 to that in 1995?
Your answer should be very brief. 0.91. What is the ratio of the Aid flow (current US$) in Myanmar in 1994 to that in 1995?
Give a very brief answer. 37.57. What is the ratio of the Aid flow (current US$) in Nicaragua in 1994 to that in 1995?
Make the answer very short. 1.12. What is the ratio of the Aid flow (current US$) of Romania in 1994 to that in 1995?
Your answer should be compact. 0.94. What is the ratio of the Aid flow (current US$) in Guinea-Bissau in 1994 to that in 1996?
Provide a succinct answer. 1.23. What is the ratio of the Aid flow (current US$) in Myanmar in 1994 to that in 1996?
Provide a short and direct response. 10.96. What is the ratio of the Aid flow (current US$) in Nicaragua in 1994 to that in 1996?
Keep it short and to the point. 0.71. What is the ratio of the Aid flow (current US$) in Romania in 1994 to that in 1996?
Your answer should be very brief. 1. What is the ratio of the Aid flow (current US$) in Guinea-Bissau in 1994 to that in 1997?
Your answer should be very brief. 2.82. What is the ratio of the Aid flow (current US$) of Myanmar in 1994 to that in 1997?
Offer a very short reply. 37.57. What is the ratio of the Aid flow (current US$) of Nicaragua in 1994 to that in 1997?
Provide a succinct answer. 1.11. What is the ratio of the Aid flow (current US$) of Romania in 1994 to that in 1997?
Your answer should be very brief. 1.76. What is the ratio of the Aid flow (current US$) of Guinea-Bissau in 1994 to that in 1998?
Your answer should be compact. 1.37. What is the ratio of the Aid flow (current US$) in Myanmar in 1994 to that in 1998?
Offer a terse response. 43.83. What is the ratio of the Aid flow (current US$) in Nicaragua in 1994 to that in 1998?
Make the answer very short. 0.7. What is the ratio of the Aid flow (current US$) in Romania in 1994 to that in 1998?
Your response must be concise. 1.6. What is the ratio of the Aid flow (current US$) of Guinea-Bissau in 1995 to that in 1996?
Offer a very short reply. 1.36. What is the ratio of the Aid flow (current US$) of Myanmar in 1995 to that in 1996?
Your response must be concise. 0.29. What is the ratio of the Aid flow (current US$) in Nicaragua in 1995 to that in 1996?
Your response must be concise. 0.63. What is the ratio of the Aid flow (current US$) of Romania in 1995 to that in 1996?
Offer a terse response. 1.06. What is the ratio of the Aid flow (current US$) in Guinea-Bissau in 1995 to that in 1997?
Make the answer very short. 3.12. What is the ratio of the Aid flow (current US$) of Myanmar in 1995 to that in 1997?
Your response must be concise. 1. What is the ratio of the Aid flow (current US$) in Nicaragua in 1995 to that in 1997?
Ensure brevity in your answer.  0.98. What is the ratio of the Aid flow (current US$) in Romania in 1995 to that in 1997?
Your response must be concise. 1.86. What is the ratio of the Aid flow (current US$) in Guinea-Bissau in 1995 to that in 1998?
Keep it short and to the point. 1.51. What is the ratio of the Aid flow (current US$) of Myanmar in 1995 to that in 1998?
Make the answer very short. 1.17. What is the ratio of the Aid flow (current US$) of Nicaragua in 1995 to that in 1998?
Provide a succinct answer. 0.63. What is the ratio of the Aid flow (current US$) in Romania in 1995 to that in 1998?
Your response must be concise. 1.7. What is the ratio of the Aid flow (current US$) of Guinea-Bissau in 1996 to that in 1997?
Offer a terse response. 2.29. What is the ratio of the Aid flow (current US$) of Myanmar in 1996 to that in 1997?
Make the answer very short. 3.43. What is the ratio of the Aid flow (current US$) in Nicaragua in 1996 to that in 1997?
Offer a terse response. 1.57. What is the ratio of the Aid flow (current US$) of Romania in 1996 to that in 1997?
Give a very brief answer. 1.76. What is the ratio of the Aid flow (current US$) of Guinea-Bissau in 1996 to that in 1998?
Offer a terse response. 1.11. What is the ratio of the Aid flow (current US$) of Romania in 1996 to that in 1998?
Give a very brief answer. 1.6. What is the ratio of the Aid flow (current US$) of Guinea-Bissau in 1997 to that in 1998?
Ensure brevity in your answer.  0.49. What is the ratio of the Aid flow (current US$) of Nicaragua in 1997 to that in 1998?
Your answer should be very brief. 0.64. What is the ratio of the Aid flow (current US$) of Romania in 1997 to that in 1998?
Your answer should be compact. 0.91. What is the difference between the highest and the second highest Aid flow (current US$) of Myanmar?
Your answer should be very brief. 2.35e+06. What is the difference between the highest and the second highest Aid flow (current US$) of Nicaragua?
Your answer should be compact. 6.89e+06. What is the difference between the highest and the second highest Aid flow (current US$) of Romania?
Make the answer very short. 1.40e+05. What is the difference between the highest and the lowest Aid flow (current US$) in Myanmar?
Offer a terse response. 2.57e+06. What is the difference between the highest and the lowest Aid flow (current US$) of Nicaragua?
Your answer should be very brief. 1.38e+07. What is the difference between the highest and the lowest Aid flow (current US$) of Romania?
Give a very brief answer. 2.05e+06. 